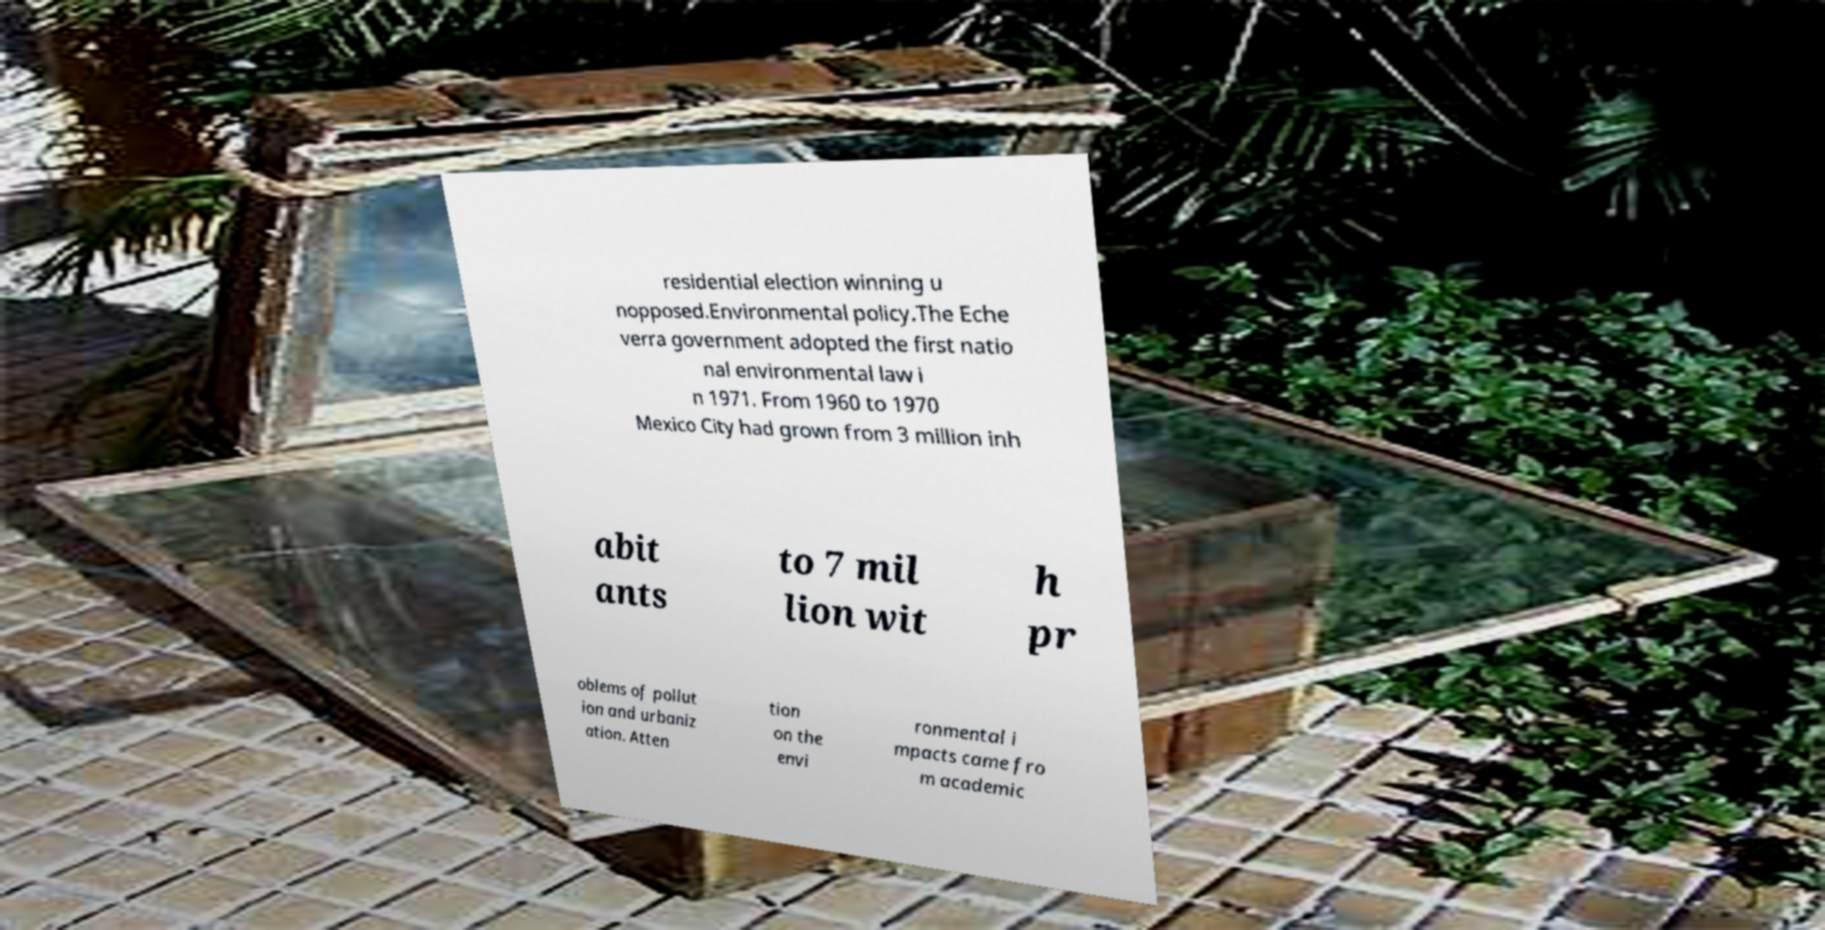Can you accurately transcribe the text from the provided image for me? residential election winning u nopposed.Environmental policy.The Eche verra government adopted the first natio nal environmental law i n 1971. From 1960 to 1970 Mexico City had grown from 3 million inh abit ants to 7 mil lion wit h pr oblems of pollut ion and urbaniz ation. Atten tion on the envi ronmental i mpacts came fro m academic 